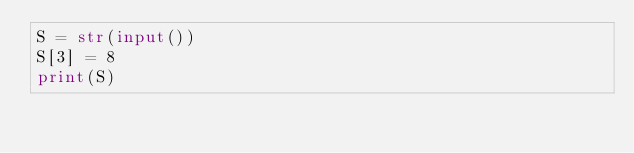Convert code to text. <code><loc_0><loc_0><loc_500><loc_500><_Python_>S = str(input())
S[3] = 8
print(S)</code> 